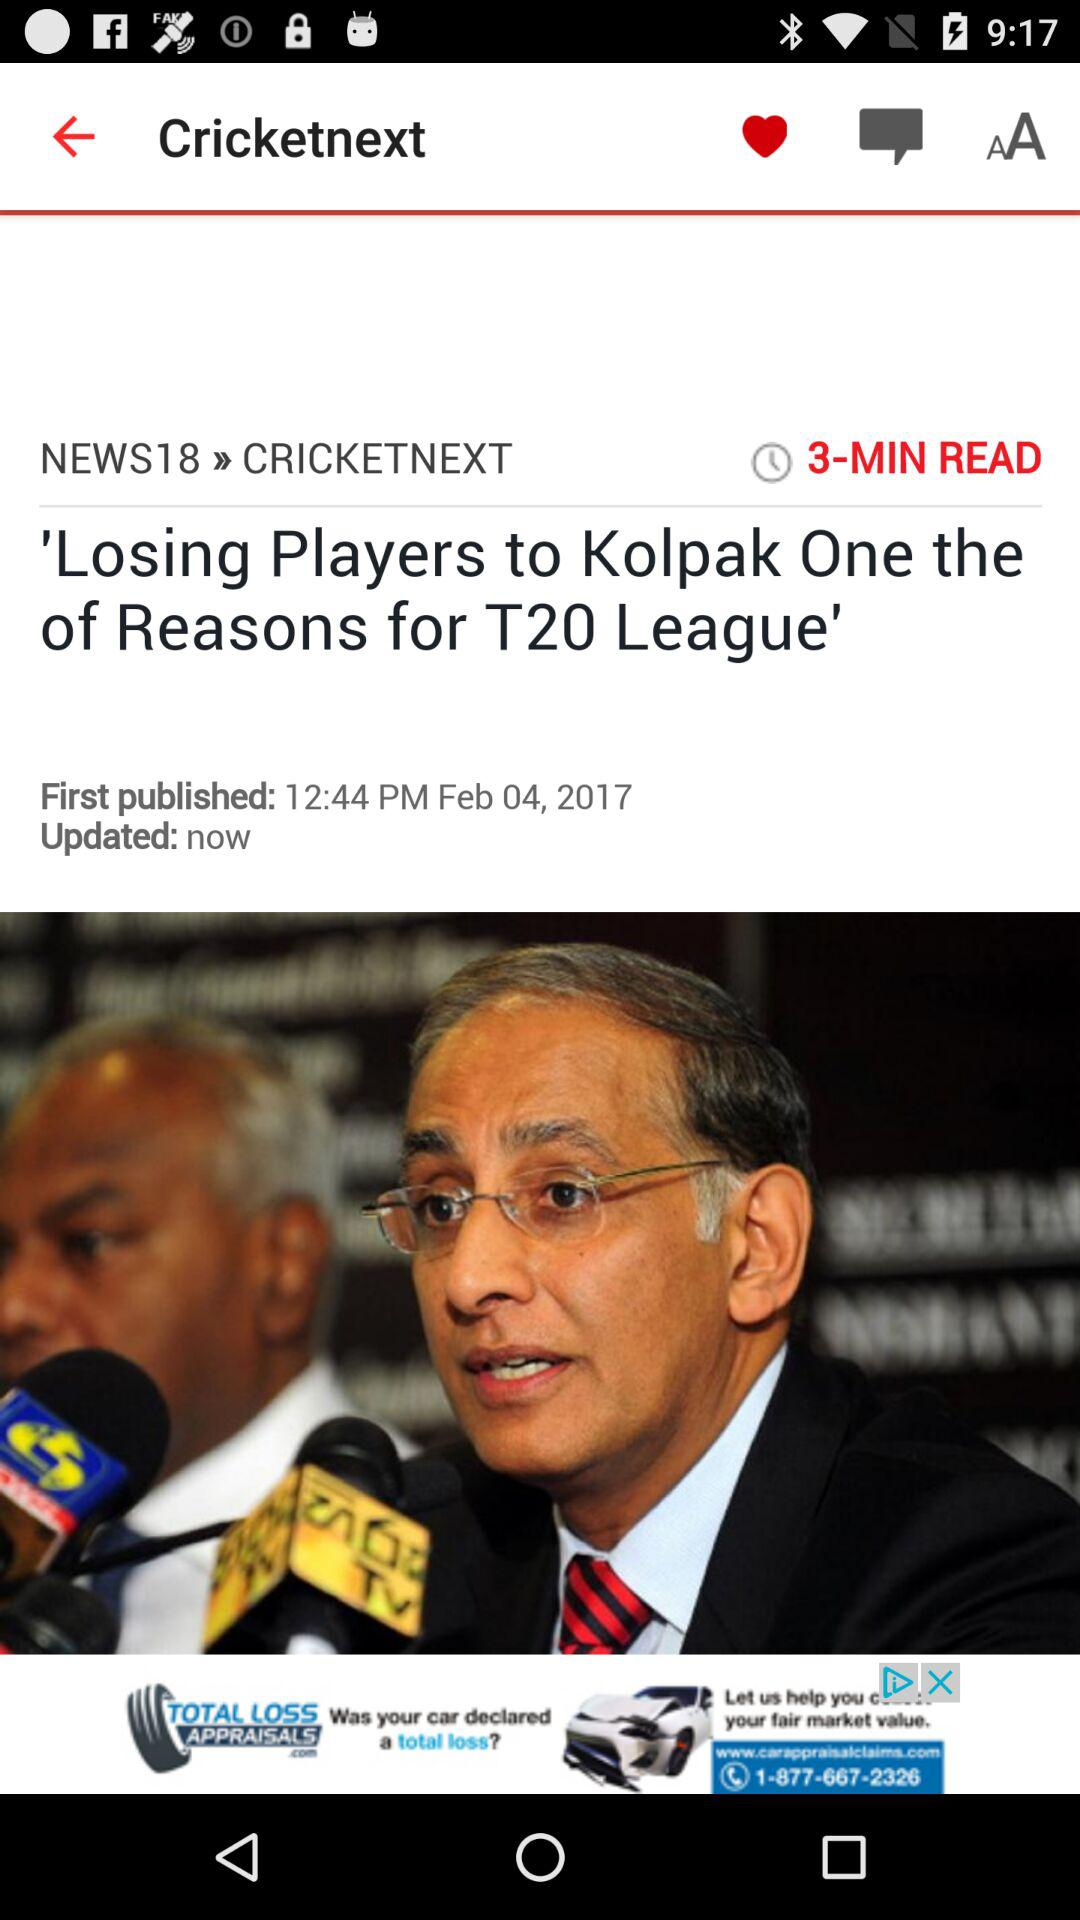How many minutes are required to read? There are 3 minutes required to read. 